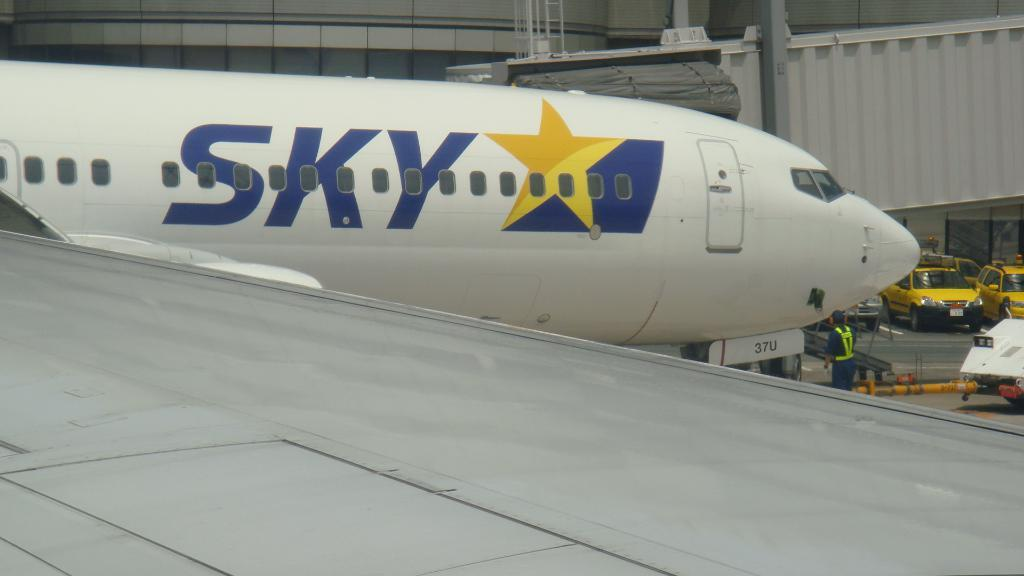What is the main subject of the image? The main subject of the image is an airplane. What else can be seen in the image besides the airplane? There are vehicles and a person visible in the image. What can be seen in the background of the image? There are poles and a wall in the background of the image. What month is it in the image? There is no indication of a specific month in the image. Can you see any pipes in the image? There are no pipes present in the image. 